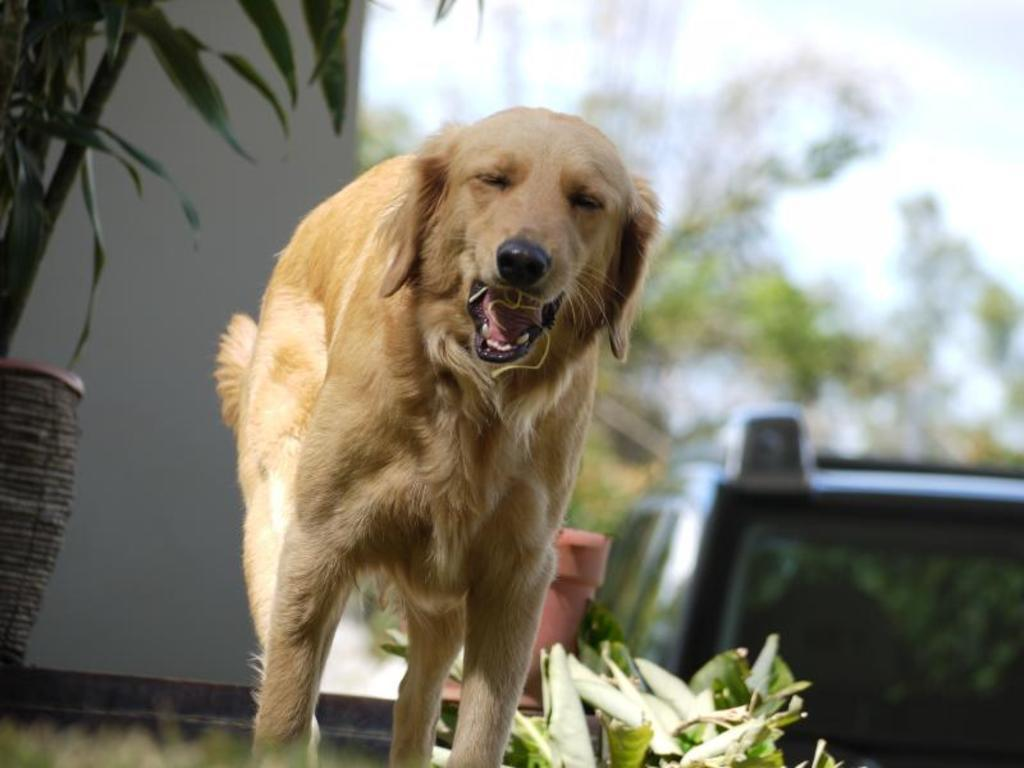What is the main subject of the image? The main subject of the image is a dog. What is the dog doing in the image? The dog is standing in the image. What is in the dog's mouth? The dog has a thread in its mouth. What can be seen in the background of the image? There are plants, a wall, and a vehicle in the background of the image. How would you describe the background view? The background view is blurry. What type of pie is the dog eating in the image? There is no pie present in the image; the dog has a thread in its mouth. Can you tell me how many aunts are visible in the image? There are no aunts present in the image; the main subject is a dog. 